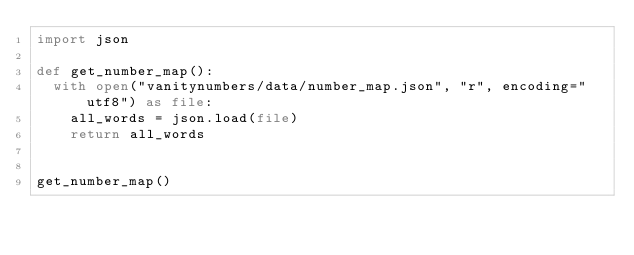<code> <loc_0><loc_0><loc_500><loc_500><_Python_>import json

def get_number_map():
  with open("vanitynumbers/data/number_map.json", "r", encoding="utf8") as file:
    all_words = json.load(file)
    return all_words


get_number_map()
</code> 